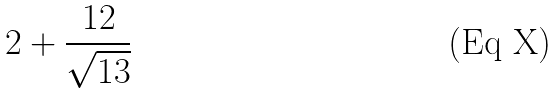<formula> <loc_0><loc_0><loc_500><loc_500>2 + \frac { 1 2 } { \sqrt { 1 3 } }</formula> 